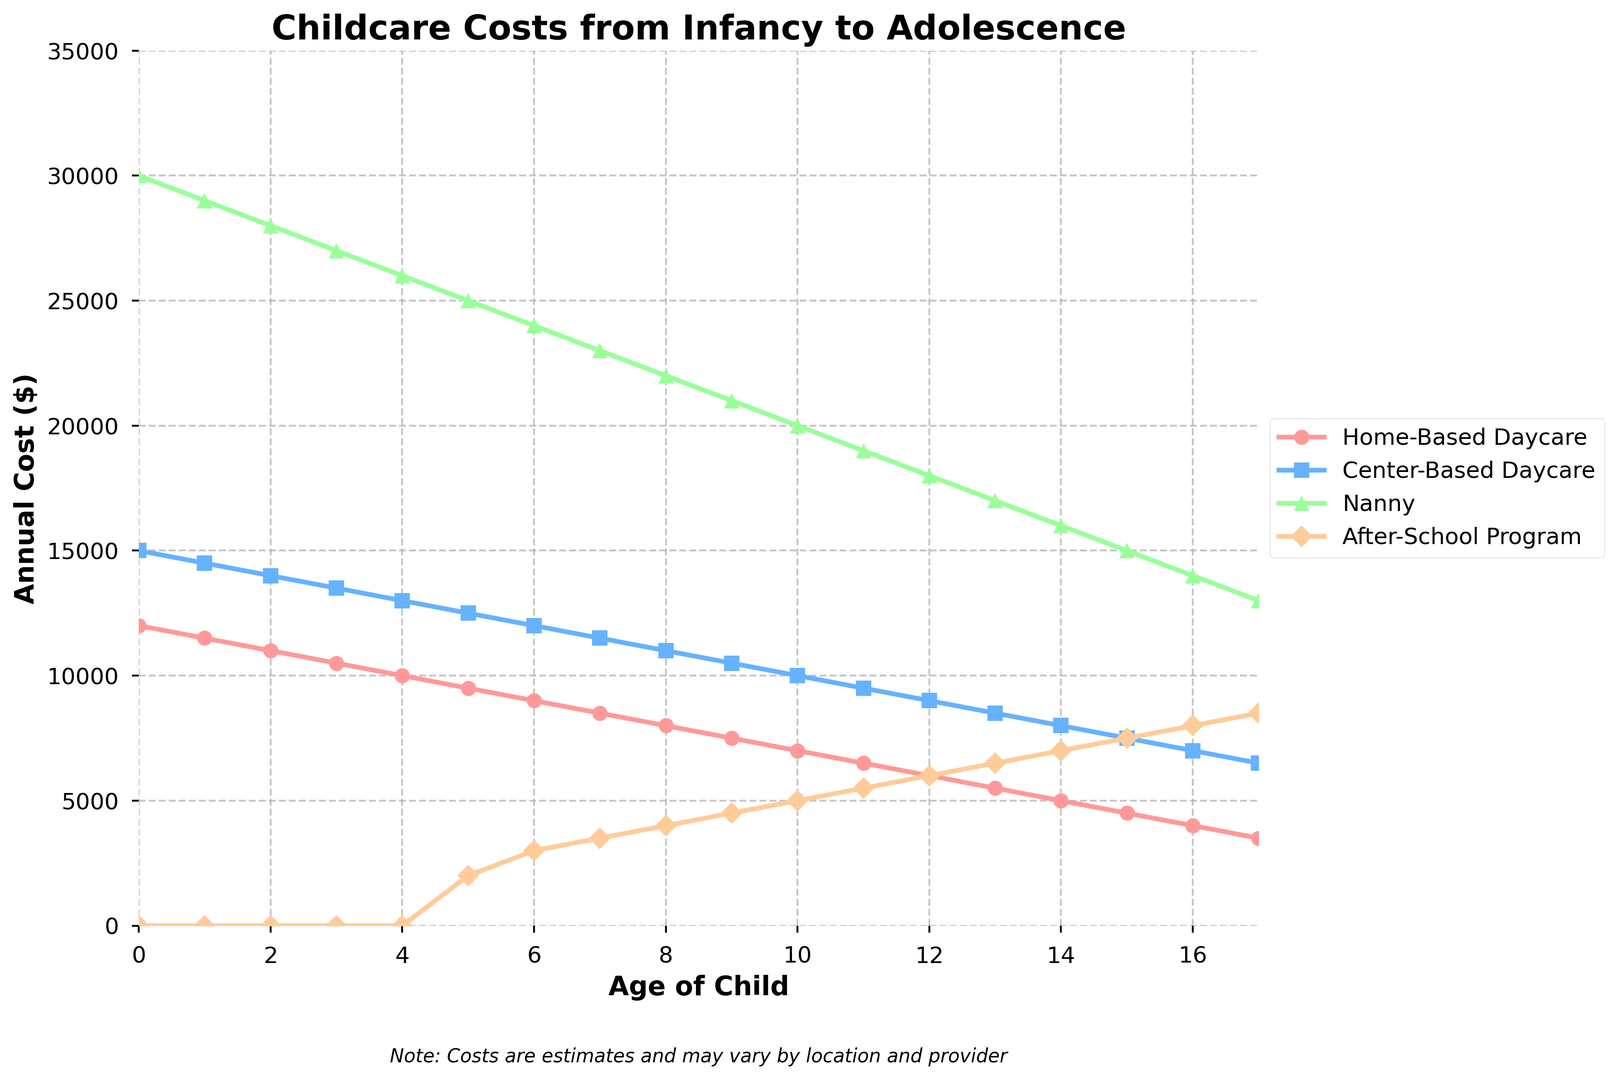What is the difference in annual cost between a Nanny and Home-Based Daycare for a 2-year-old? To find the difference, look at the costs for a 2-year-old: Nanny costs $28000 and Home-Based Daycare costs $11000. Subtract the two amounts: $28000 - $11000 = $17000
Answer: $17000 At what child age do Home-Based Daycare and Center-Based Daycare costs equal each other? As seen from the graph, Home-Based Daycare costs $4000 at age 16, which is equal to Center-Based Daycare at the same age.
Answer: 16 How much more does a Nanny cost compared to an After-School Program at age 15? Look at the costs for a 15-year-old: Nanny costs $15000 and After-School Program costs $7500. Subtract the After-School Program cost from the Nanny cost: $15000 - $7500 = $7500
Answer: $7500 What is the average cost of Center-Based Daycare from ages 5 to 10? Sum the Center-Based Daycare costs for ages 5 to 10 ($12500 + $12000 + $11500 + $11000 + $10500 + $10000), then divide by the number of ages (6): (12500 + 12000 + 11500 + 11000 + 10500 + 10000) / 6 = $11250
Answer: $11250 Which childcare option becomes the least expensive by age 17? At age 17, compare the costs: Home-Based Daycare is $3500, Center-Based Daycare is $6500, Nanny is $13000, and After-School Program is $8500. Home-Based Daycare is the least expensive.
Answer: Home-Based Daycare For a 6-year-old child, what is the combined cost of a Nanny and an After-School Program? Sum the Nanny cost and After-School Program cost for a 6-year-old: $24000 (Nanny) + $3000 (After-School Program) = $27000
Answer: $27000 Which childcare option shows the steepest decline in cost from age 0 to age 17? Compare the cost difference from age 0 to 17 for each option: Home-Based Daycare drops from $12000 to $3500, Center-Based Daycare from $15000 to $6500, Nanny from $30000 to $13000, and After-School Program starts at $0 and ends at $8500. Nanny has the steepest decline of $17000 ($30000 - $13000).
Answer: Nanny At what age does the After-School Program start incurring costs? The graph shows that the After-School Program cost starts at age 5.
Answer: 5 Between ages 3 and 7, which childcare option consistently costs the least? Look at the costs between ages 3 and 7: Home-Based Daycare consistently has the lowest cost compared to the other options during these years.
Answer: Home-Based Daycare If a parent uses Home-Based Daycare until the child turns 5 and then switches to an After-School Program, what is the total cost by age 10? Calculate the total costs from 0 to 5 for Home-Based Daycare ($12000 + $11500 + $11000 + $10500 + $10000 + $9500) = $64500, and add the costs from 6 to 10 for the After-School Program ($3000 + $3500 + $4000 + $4500 + $5000) = $20000. Total cost: $64500 + $20000 = $84500
Answer: $84500 